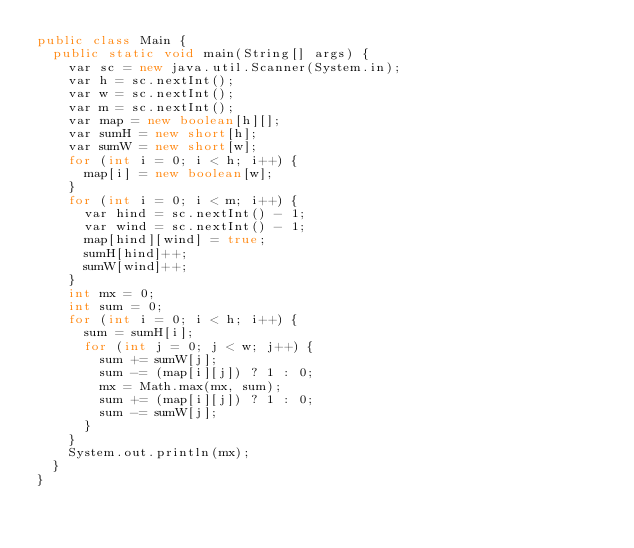<code> <loc_0><loc_0><loc_500><loc_500><_Java_>public class Main {
	public static void main(String[] args) {
		var sc = new java.util.Scanner(System.in);
		var h = sc.nextInt();
		var w = sc.nextInt();
		var m = sc.nextInt();
		var map = new boolean[h][];
		var sumH = new short[h];
		var sumW = new short[w];
		for (int i = 0; i < h; i++) {
			map[i] = new boolean[w];
		}
		for (int i = 0; i < m; i++) {
			var hind = sc.nextInt() - 1;
			var wind = sc.nextInt() - 1;
			map[hind][wind] = true;
			sumH[hind]++;
			sumW[wind]++;
		}
		int mx = 0;
		int sum = 0;
		for (int i = 0; i < h; i++) {
			sum = sumH[i];
			for (int j = 0; j < w; j++) {
				sum += sumW[j];
				sum -= (map[i][j]) ? 1 : 0;
				mx = Math.max(mx, sum);
				sum += (map[i][j]) ? 1 : 0;
				sum -= sumW[j];
			}
		}
		System.out.println(mx);
	}
}</code> 